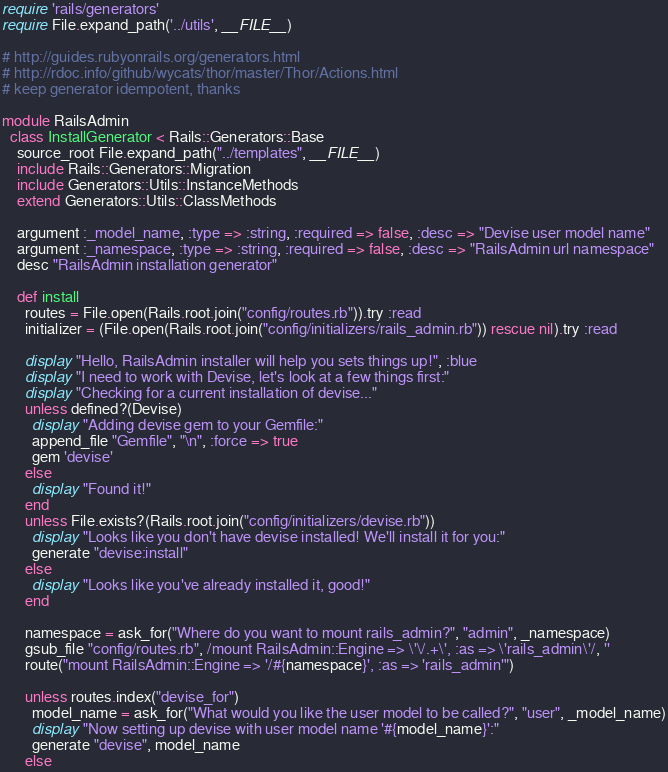Convert code to text. <code><loc_0><loc_0><loc_500><loc_500><_Ruby_>require 'rails/generators'
require File.expand_path('../utils', __FILE__)

# http://guides.rubyonrails.org/generators.html
# http://rdoc.info/github/wycats/thor/master/Thor/Actions.html
# keep generator idempotent, thanks

module RailsAdmin
  class InstallGenerator < Rails::Generators::Base
    source_root File.expand_path("../templates", __FILE__)
    include Rails::Generators::Migration
    include Generators::Utils::InstanceMethods
    extend Generators::Utils::ClassMethods

    argument :_model_name, :type => :string, :required => false, :desc => "Devise user model name"
    argument :_namespace, :type => :string, :required => false, :desc => "RailsAdmin url namespace"
    desc "RailsAdmin installation generator"

    def install
      routes = File.open(Rails.root.join("config/routes.rb")).try :read
      initializer = (File.open(Rails.root.join("config/initializers/rails_admin.rb")) rescue nil).try :read

      display "Hello, RailsAdmin installer will help you sets things up!", :blue
      display "I need to work with Devise, let's look at a few things first:"
      display "Checking for a current installation of devise..."
      unless defined?(Devise)
        display "Adding devise gem to your Gemfile:"
        append_file "Gemfile", "\n", :force => true
        gem 'devise'
      else
        display "Found it!"
      end
      unless File.exists?(Rails.root.join("config/initializers/devise.rb"))
        display "Looks like you don't have devise installed! We'll install it for you:"
        generate "devise:install"
      else
        display "Looks like you've already installed it, good!"
      end

      namespace = ask_for("Where do you want to mount rails_admin?", "admin", _namespace)
      gsub_file "config/routes.rb", /mount RailsAdmin::Engine => \'\/.+\', :as => \'rails_admin\'/, ''
      route("mount RailsAdmin::Engine => '/#{namespace}', :as => 'rails_admin'")

      unless routes.index("devise_for")
        model_name = ask_for("What would you like the user model to be called?", "user", _model_name)
        display "Now setting up devise with user model name '#{model_name}':"
        generate "devise", model_name
      else</code> 